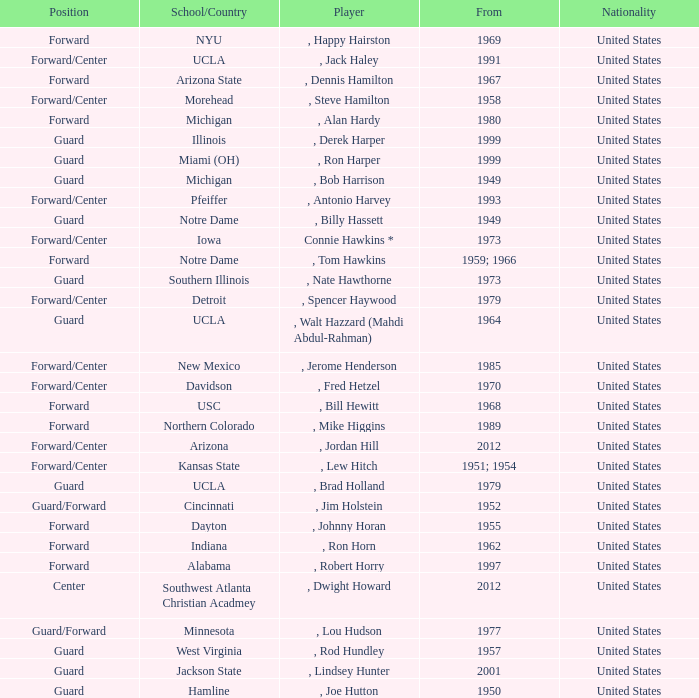Which player started in 2001? , Lindsey Hunter. 